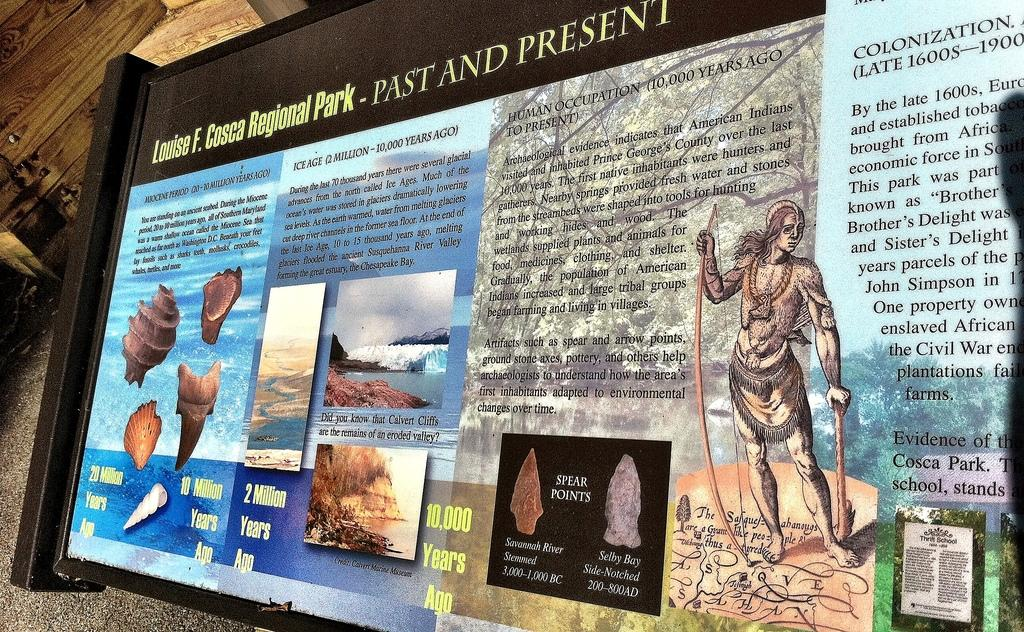What is on the wall in the image? There is a board on the wall in the image. What can be found on the board? The board contains text and photos. How does the board react to the earthquake in the image? There is no earthquake present in the image, so the board's reaction cannot be determined. 